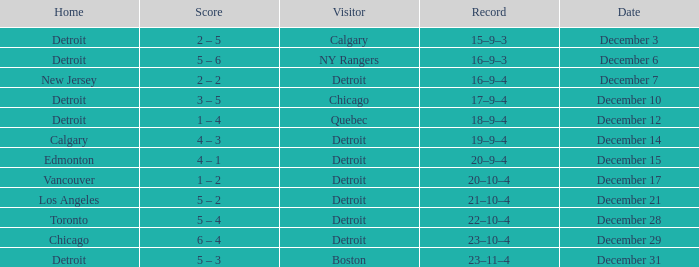Who is the visitor on december 3? Calgary. 